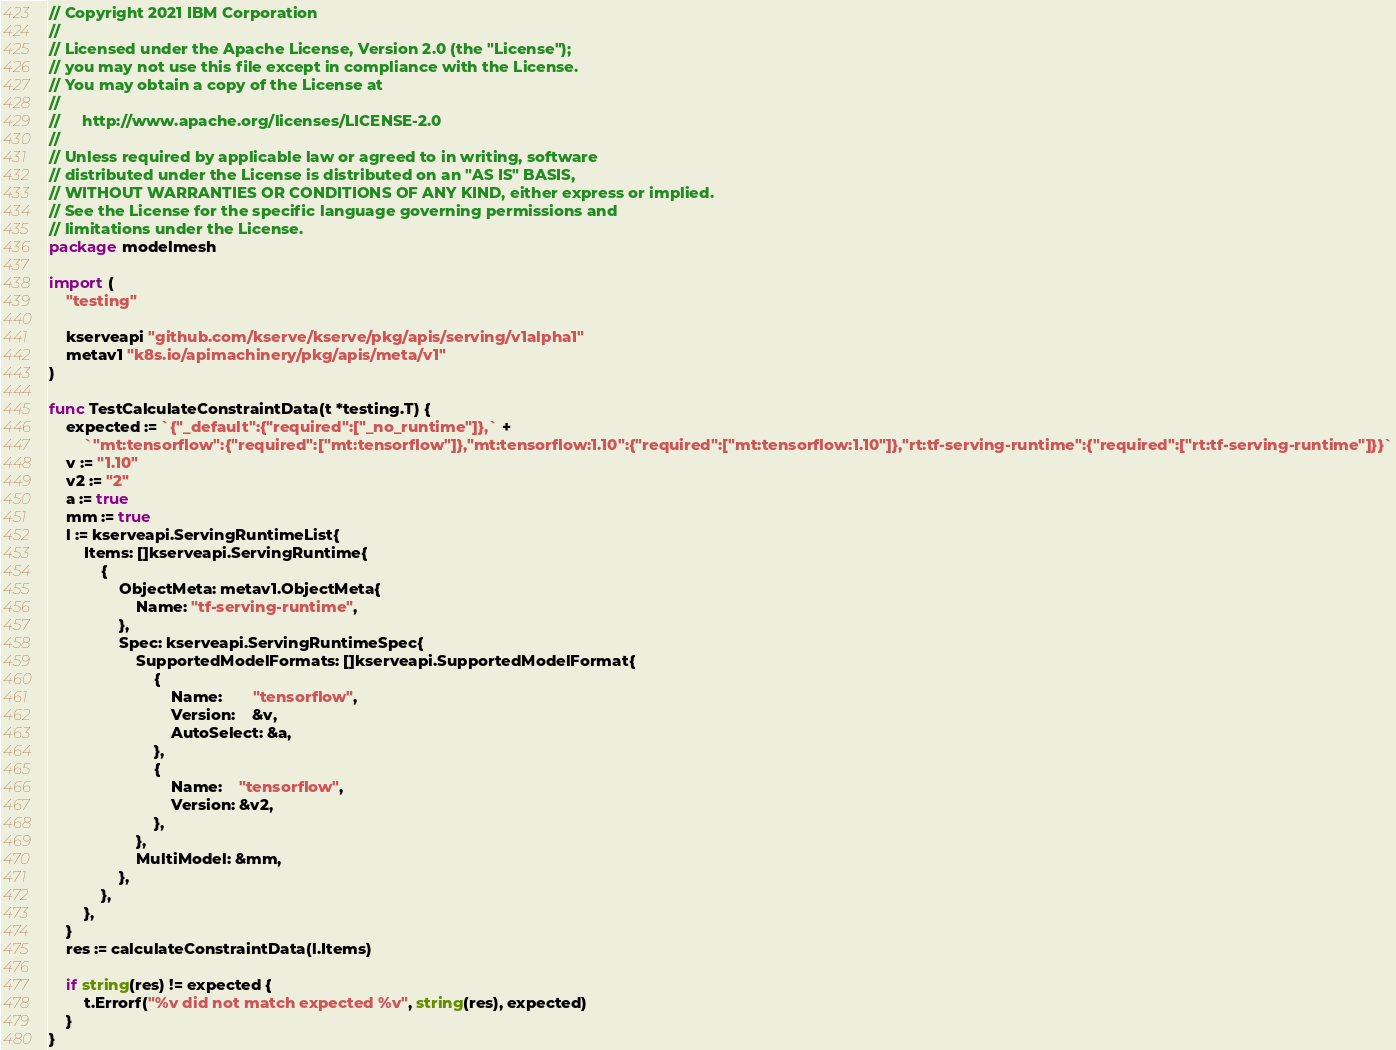<code> <loc_0><loc_0><loc_500><loc_500><_Go_>// Copyright 2021 IBM Corporation
//
// Licensed under the Apache License, Version 2.0 (the "License");
// you may not use this file except in compliance with the License.
// You may obtain a copy of the License at
//
//     http://www.apache.org/licenses/LICENSE-2.0
//
// Unless required by applicable law or agreed to in writing, software
// distributed under the License is distributed on an "AS IS" BASIS,
// WITHOUT WARRANTIES OR CONDITIONS OF ANY KIND, either express or implied.
// See the License for the specific language governing permissions and
// limitations under the License.
package modelmesh

import (
	"testing"

	kserveapi "github.com/kserve/kserve/pkg/apis/serving/v1alpha1"
	metav1 "k8s.io/apimachinery/pkg/apis/meta/v1"
)

func TestCalculateConstraintData(t *testing.T) {
	expected := `{"_default":{"required":["_no_runtime"]},` +
		`"mt:tensorflow":{"required":["mt:tensorflow"]},"mt:tensorflow:1.10":{"required":["mt:tensorflow:1.10"]},"rt:tf-serving-runtime":{"required":["rt:tf-serving-runtime"]}}`
	v := "1.10"
	v2 := "2"
	a := true
	mm := true
	l := kserveapi.ServingRuntimeList{
		Items: []kserveapi.ServingRuntime{
			{
				ObjectMeta: metav1.ObjectMeta{
					Name: "tf-serving-runtime",
				},
				Spec: kserveapi.ServingRuntimeSpec{
					SupportedModelFormats: []kserveapi.SupportedModelFormat{
						{
							Name:       "tensorflow",
							Version:    &v,
							AutoSelect: &a,
						},
						{
							Name:    "tensorflow",
							Version: &v2,
						},
					},
					MultiModel: &mm,
				},
			},
		},
	}
	res := calculateConstraintData(l.Items)

	if string(res) != expected {
		t.Errorf("%v did not match expected %v", string(res), expected)
	}
}
</code> 